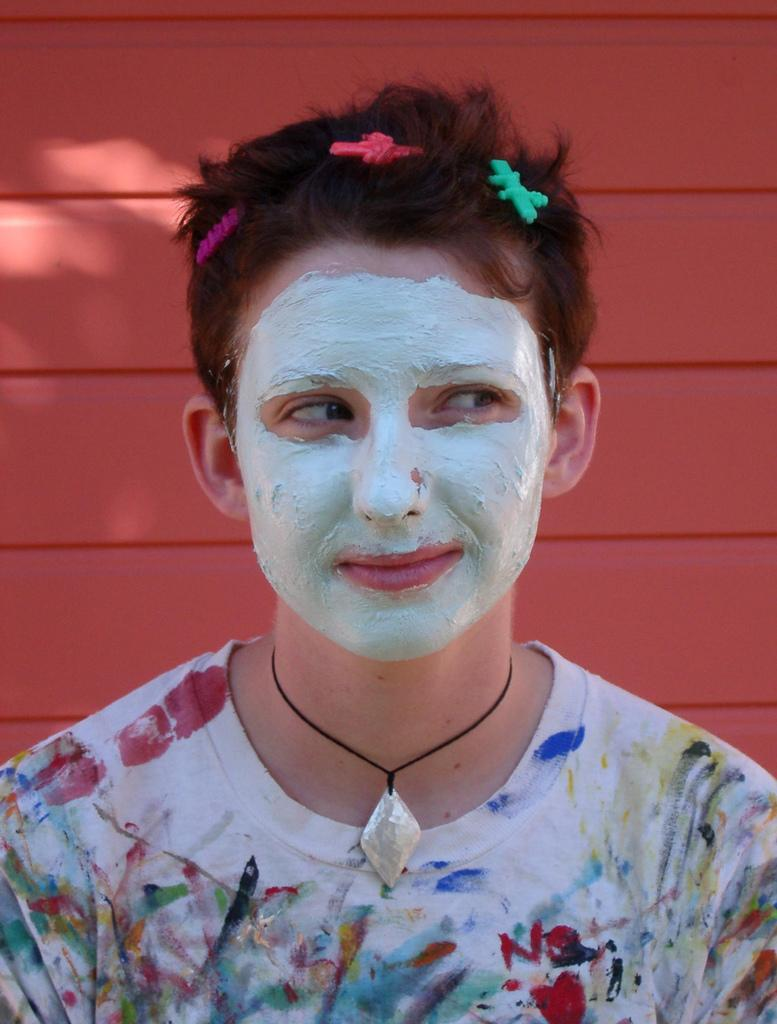Who or what is the main subject of the image? There is a person in the image. What is the person wearing? The person is wearing a dress and hair clips. What can be seen in the background of the image? There is a wall in the background of the image. What is the price of the love shown in the image? There is no indication of love or any price associated with it in the image. 